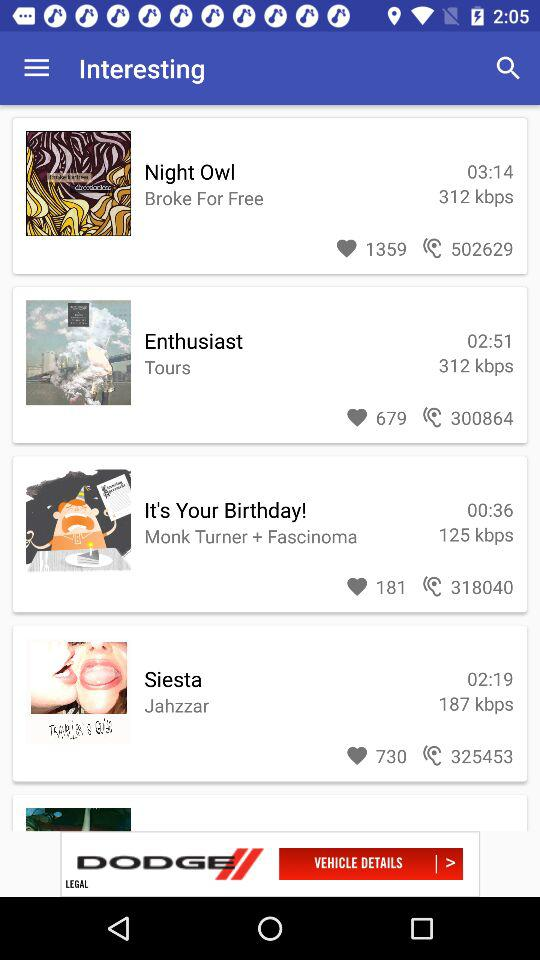How many likes on "Night Owl"? There are 1359 likes. 